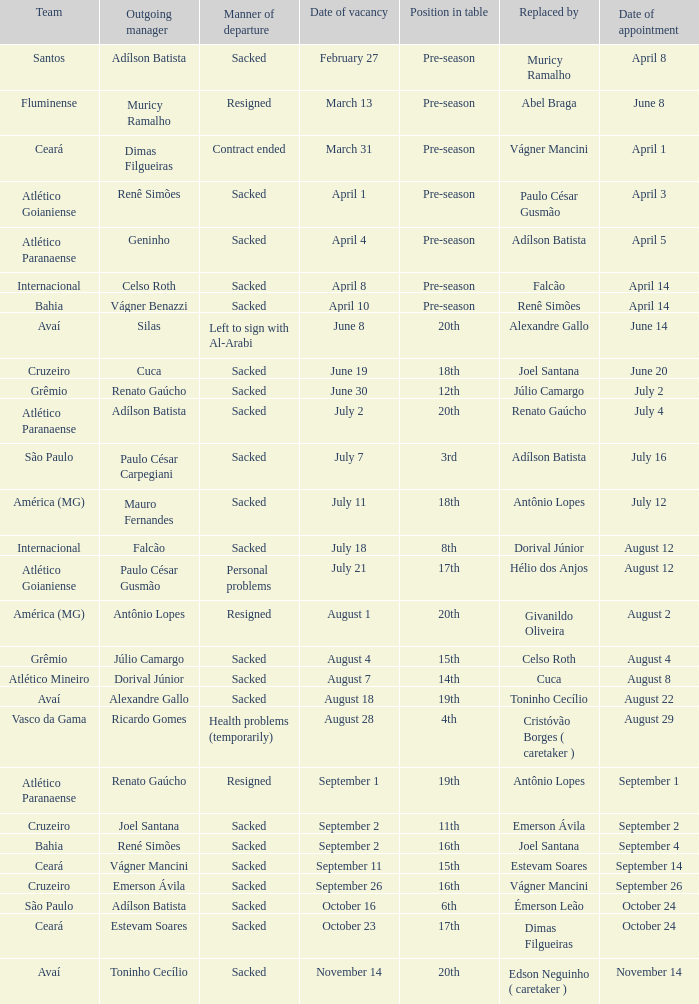What was the reason behind geninho's departure as a manager? Sacked. 